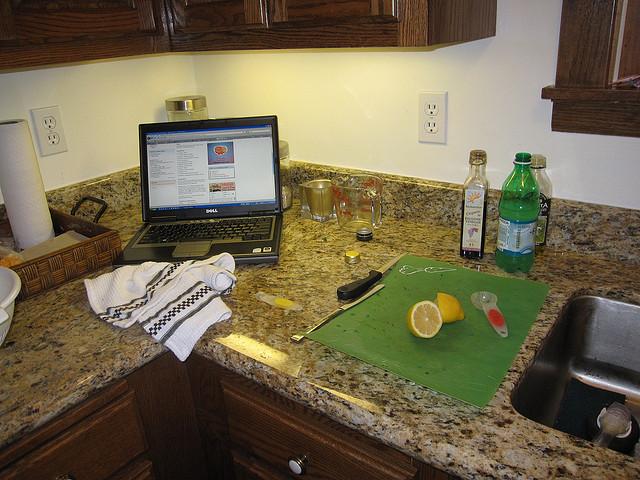What type of fruit is on the counter?
Quick response, please. Lemon. Is the computer on?
Write a very short answer. Yes. Is the lemon cut in halves?
Quick response, please. Yes. 